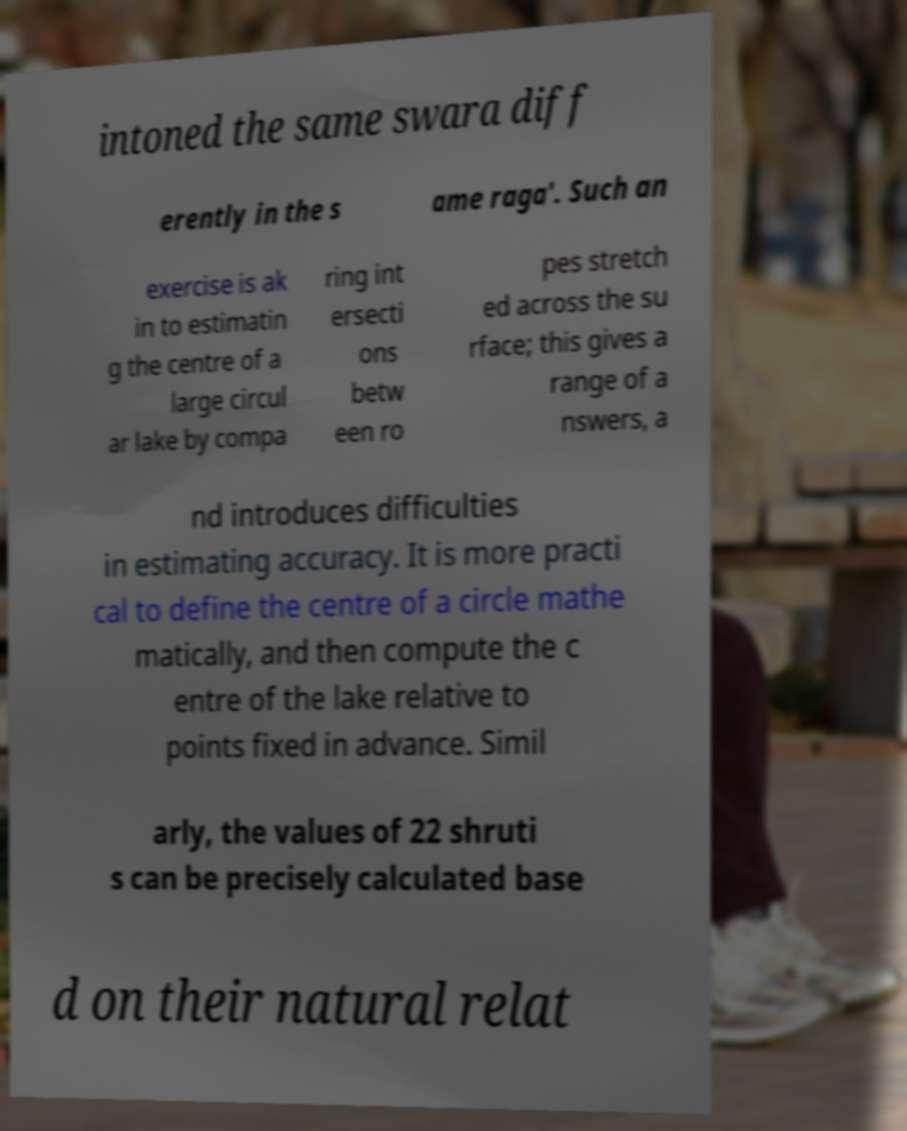Could you assist in decoding the text presented in this image and type it out clearly? intoned the same swara diff erently in the s ame raga'. Such an exercise is ak in to estimatin g the centre of a large circul ar lake by compa ring int ersecti ons betw een ro pes stretch ed across the su rface; this gives a range of a nswers, a nd introduces difficulties in estimating accuracy. It is more practi cal to define the centre of a circle mathe matically, and then compute the c entre of the lake relative to points fixed in advance. Simil arly, the values of 22 shruti s can be precisely calculated base d on their natural relat 